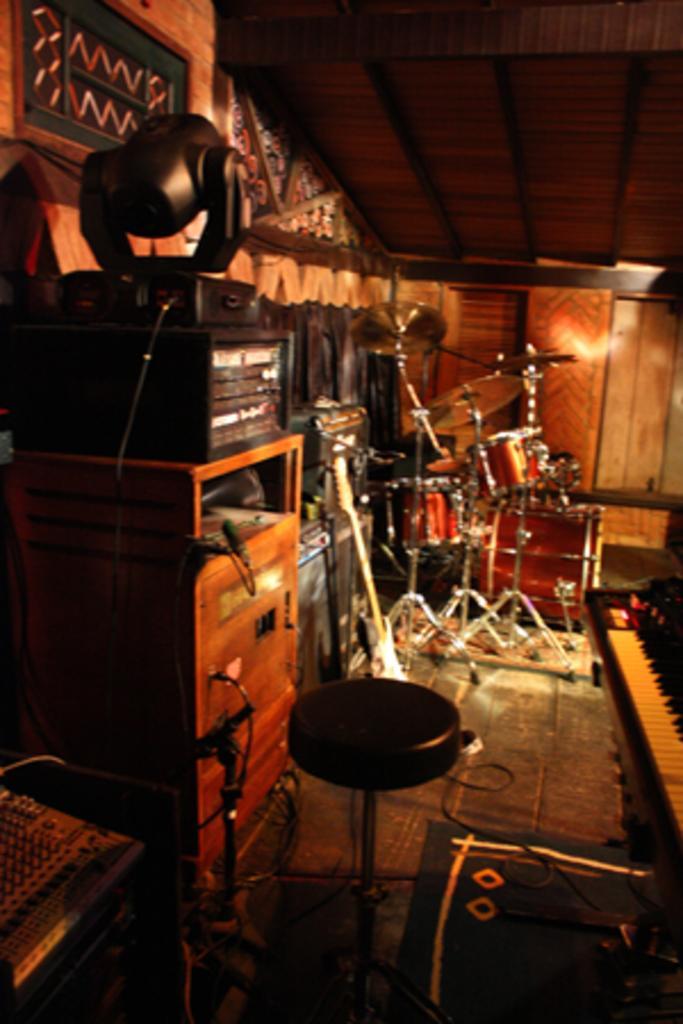How would you summarize this image in a sentence or two? This picture shows a musical instruments placed here and a sound system. Some lights here. 